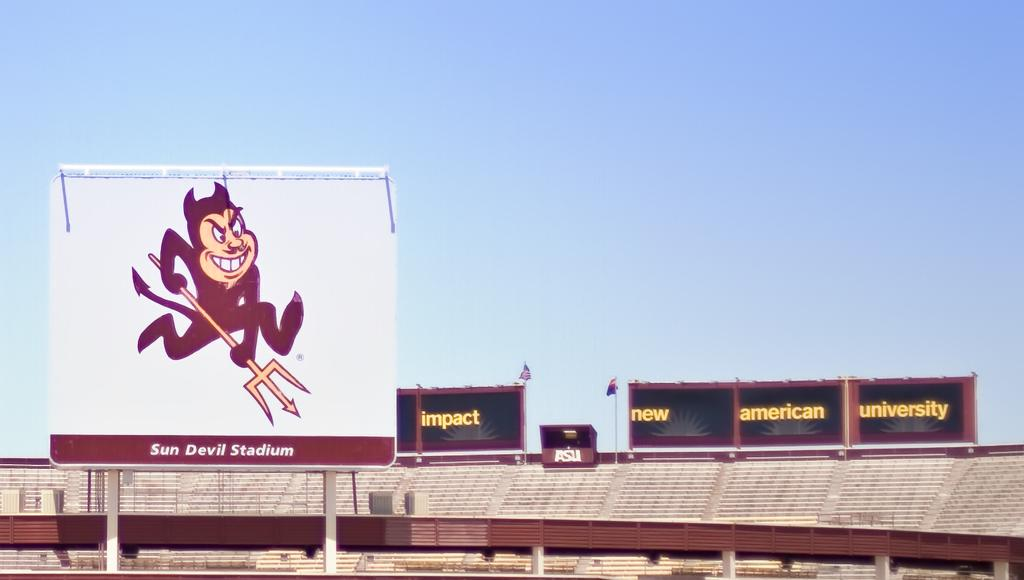Provide a one-sentence caption for the provided image. A billboard of an animation of a devil with a pitchfork at the Sun Devil Stadium. 